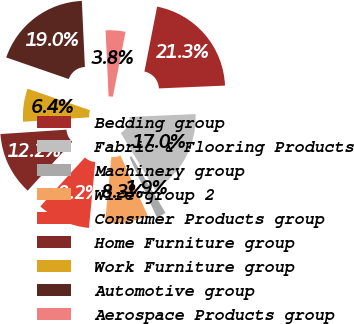Convert chart. <chart><loc_0><loc_0><loc_500><loc_500><pie_chart><fcel>Bedding group<fcel>Fabric & Flooring Products<fcel>Machinery group<fcel>Wire group 2<fcel>Consumer Products group<fcel>Home Furniture group<fcel>Work Furniture group<fcel>Automotive group<fcel>Aerospace Products group<nl><fcel>21.26%<fcel>17.04%<fcel>1.86%<fcel>8.3%<fcel>10.24%<fcel>12.18%<fcel>6.36%<fcel>18.98%<fcel>3.8%<nl></chart> 